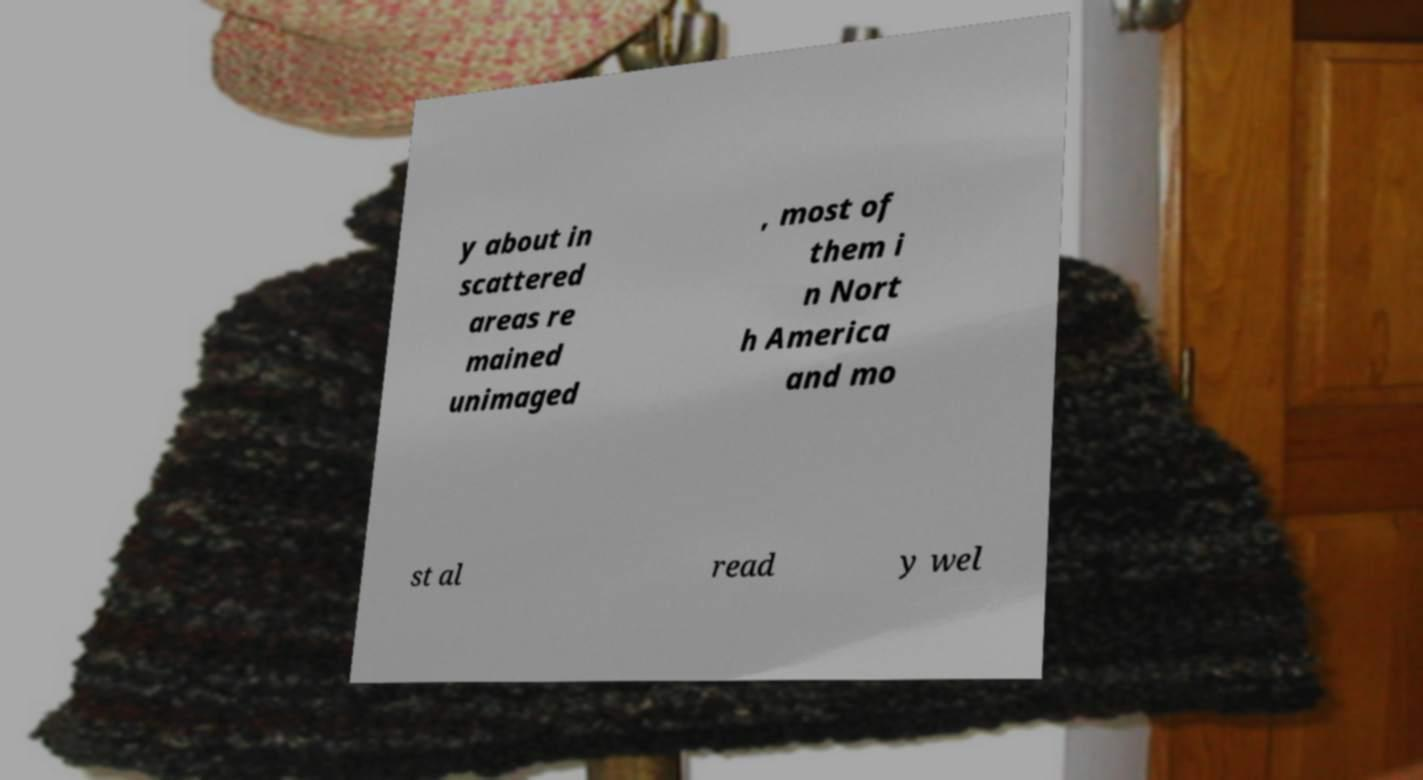Please read and relay the text visible in this image. What does it say? y about in scattered areas re mained unimaged , most of them i n Nort h America and mo st al read y wel 